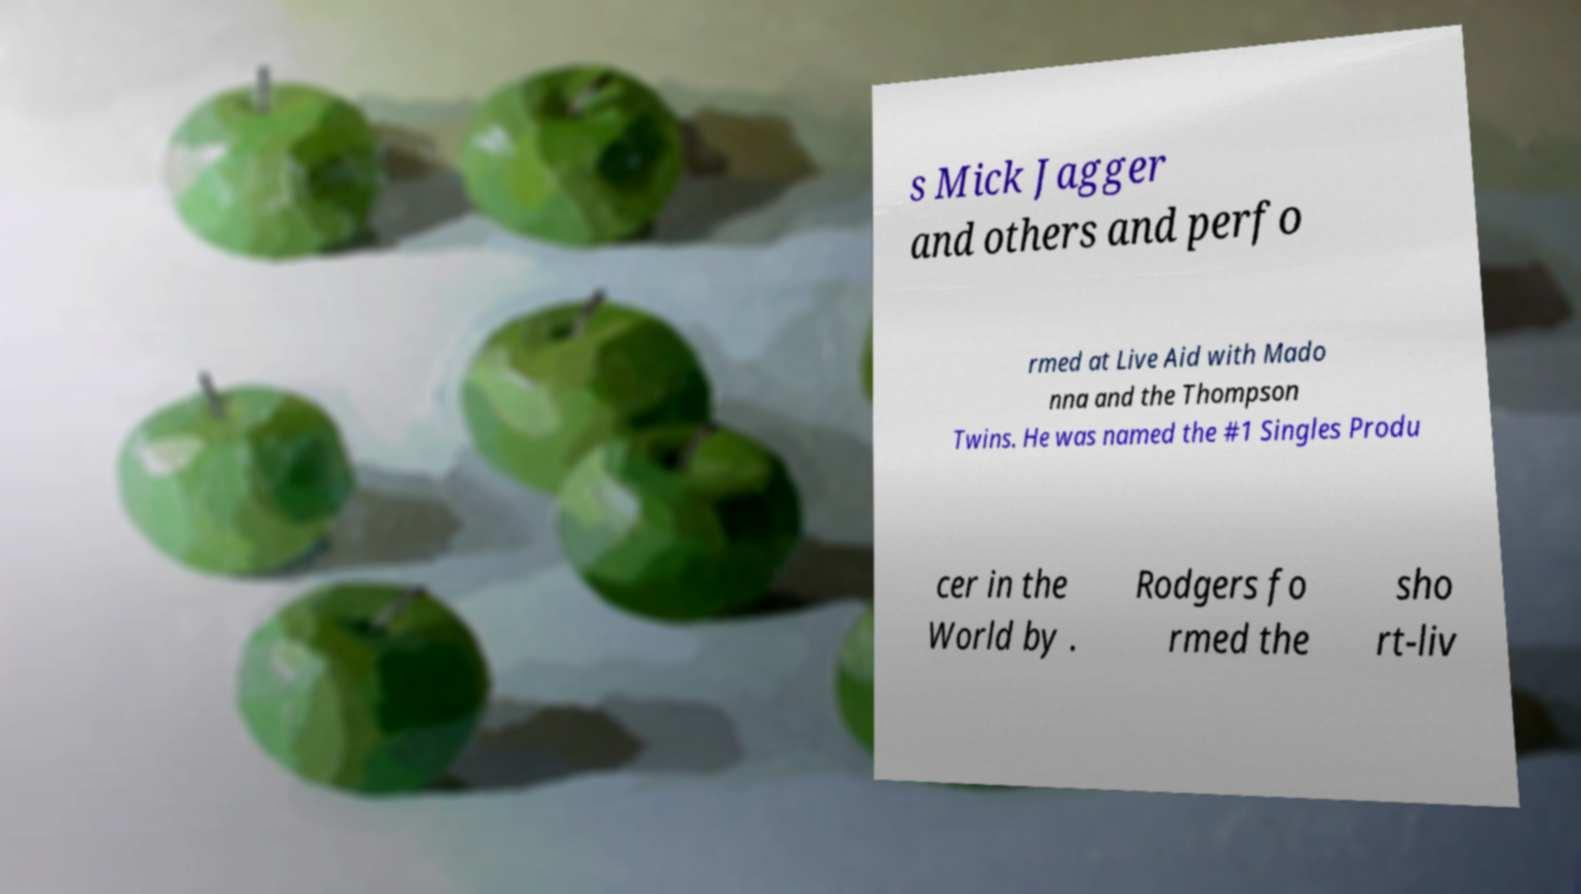Please read and relay the text visible in this image. What does it say? s Mick Jagger and others and perfo rmed at Live Aid with Mado nna and the Thompson Twins. He was named the #1 Singles Produ cer in the World by . Rodgers fo rmed the sho rt-liv 